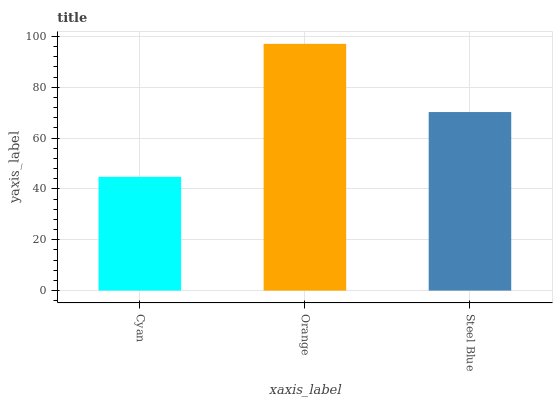Is Steel Blue the minimum?
Answer yes or no. No. Is Steel Blue the maximum?
Answer yes or no. No. Is Orange greater than Steel Blue?
Answer yes or no. Yes. Is Steel Blue less than Orange?
Answer yes or no. Yes. Is Steel Blue greater than Orange?
Answer yes or no. No. Is Orange less than Steel Blue?
Answer yes or no. No. Is Steel Blue the high median?
Answer yes or no. Yes. Is Steel Blue the low median?
Answer yes or no. Yes. Is Orange the high median?
Answer yes or no. No. Is Cyan the low median?
Answer yes or no. No. 